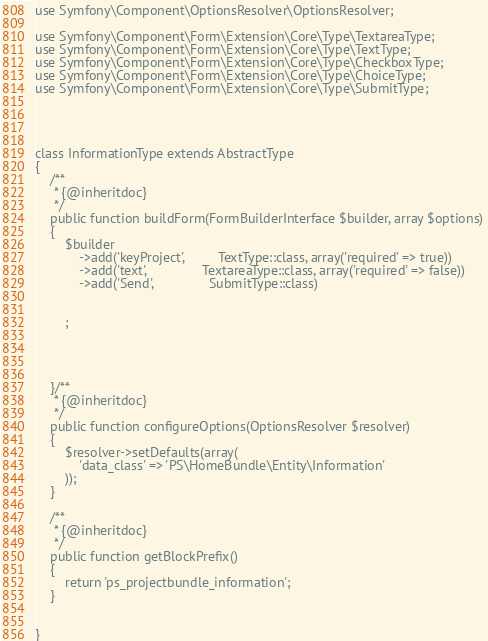<code> <loc_0><loc_0><loc_500><loc_500><_PHP_>use Symfony\Component\OptionsResolver\OptionsResolver;

use Symfony\Component\Form\Extension\Core\Type\TextareaType;
use Symfony\Component\Form\Extension\Core\Type\TextType;
use Symfony\Component\Form\Extension\Core\Type\CheckboxType;
use Symfony\Component\Form\Extension\Core\Type\ChoiceType;
use Symfony\Component\Form\Extension\Core\Type\SubmitType;




class InformationType extends AbstractType
{
    /**
     * {@inheritdoc}
     */
    public function buildForm(FormBuilderInterface $builder, array $options)
    {
        $builder
			->add('keyProject',     	TextType::class, array('required' => true))			
			->add('text',     			TextareaType::class, array('required' => false))
			->add('Send',     			SubmitType::class)
			
			
		;
		
		
		
		
    }/**
     * {@inheritdoc}
     */
    public function configureOptions(OptionsResolver $resolver)
    {
        $resolver->setDefaults(array(
            'data_class' => 'PS\HomeBundle\Entity\Information'
        ));
    }

    /**
     * {@inheritdoc}
     */
    public function getBlockPrefix()
    {
        return 'ps_projectbundle_information';
    }


}
</code> 